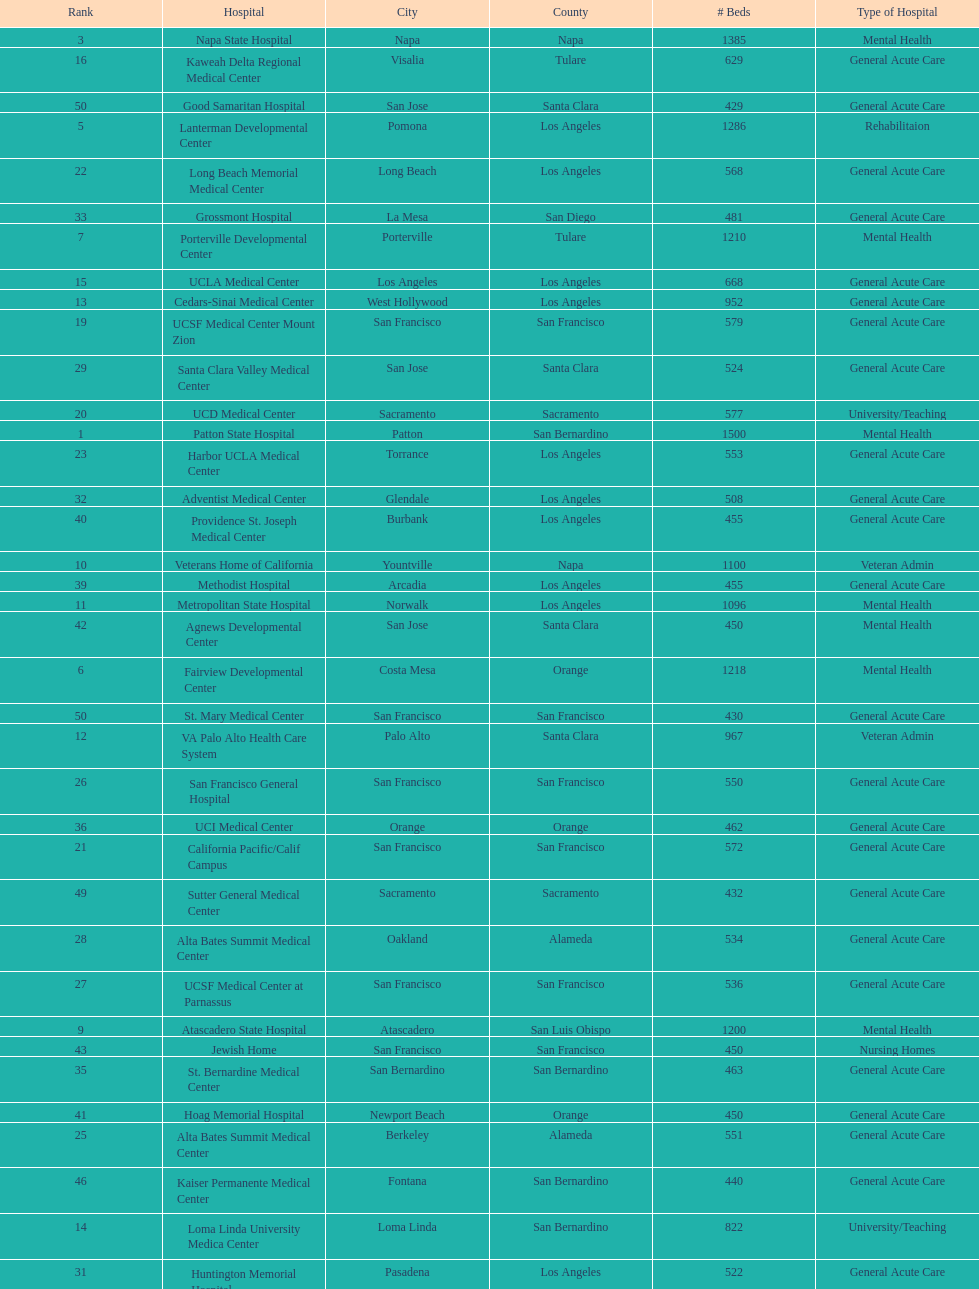What hospital in los angeles county providing hospital beds specifically for rehabilitation is ranked at least among the top 10 hospitals? Lanterman Developmental Center. 